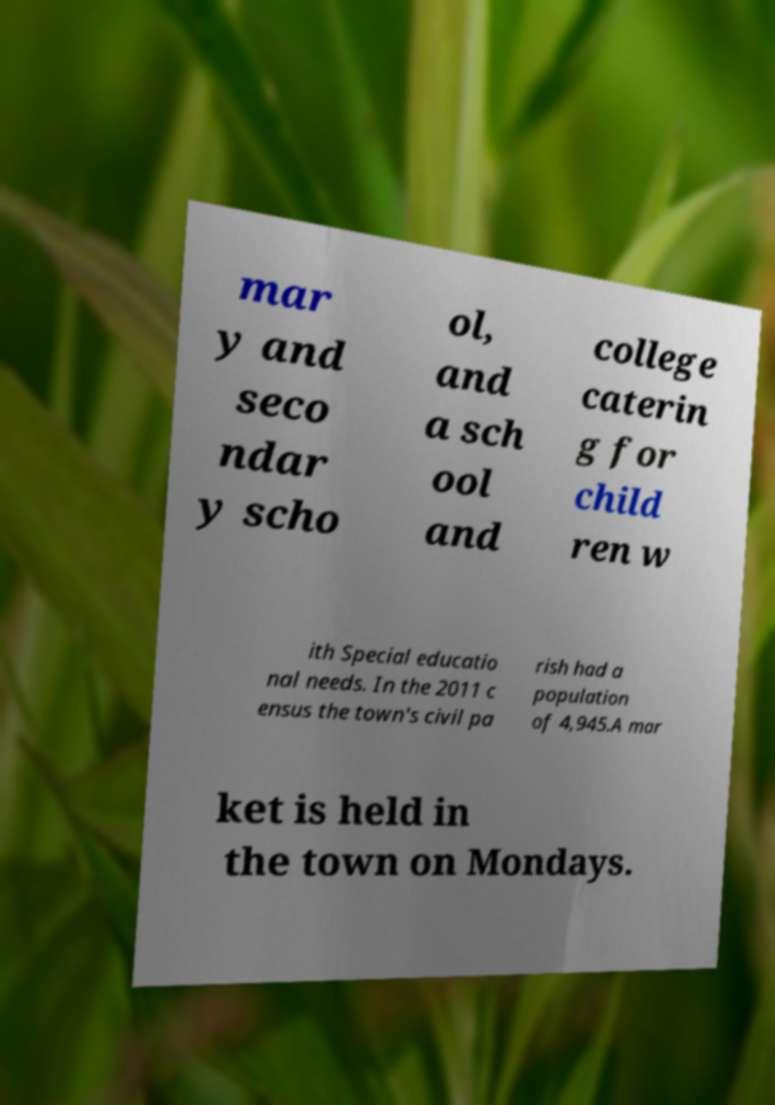Can you accurately transcribe the text from the provided image for me? mar y and seco ndar y scho ol, and a sch ool and college caterin g for child ren w ith Special educatio nal needs. In the 2011 c ensus the town's civil pa rish had a population of 4,945.A mar ket is held in the town on Mondays. 